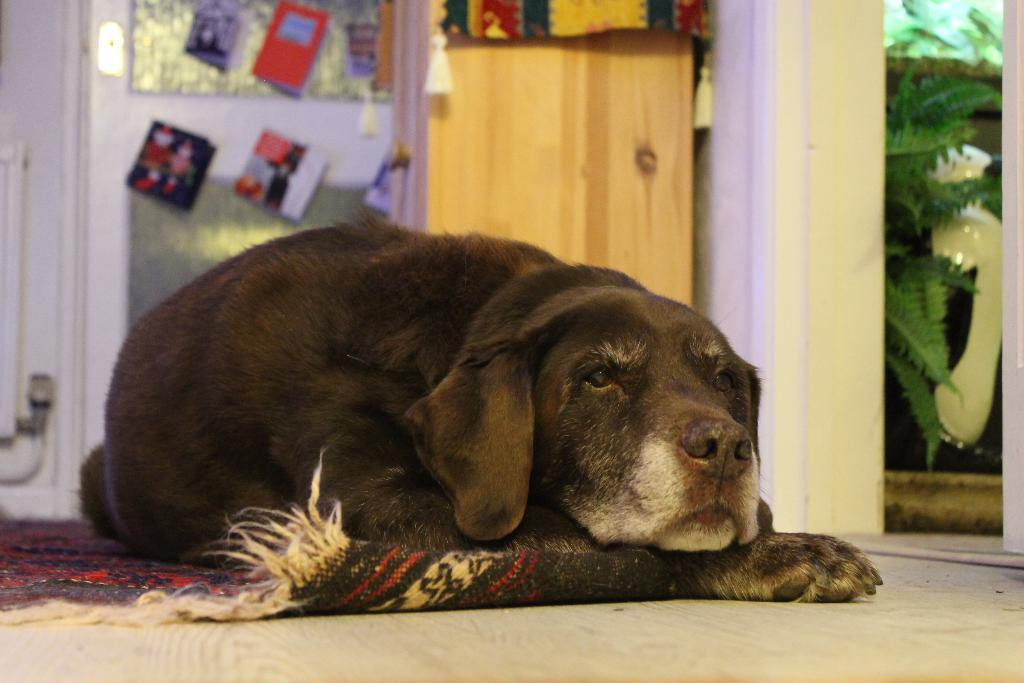What animal can be seen on the carpet in the image? There is a dog on the carpet in the image. What type of vegetation is present in the image? There are plants in the image. What type of stationery items are visible in the image? There are greeting cards in the image. What type of door can be seen in the background of the image? There appears to be a wooden door in the background. What type of material is present in the background of the image? There is a cloth in the background. How much pain is the dog experiencing in the image? There is no indication of pain in the image; the dog appears to be sitting calmly on the carpet. 